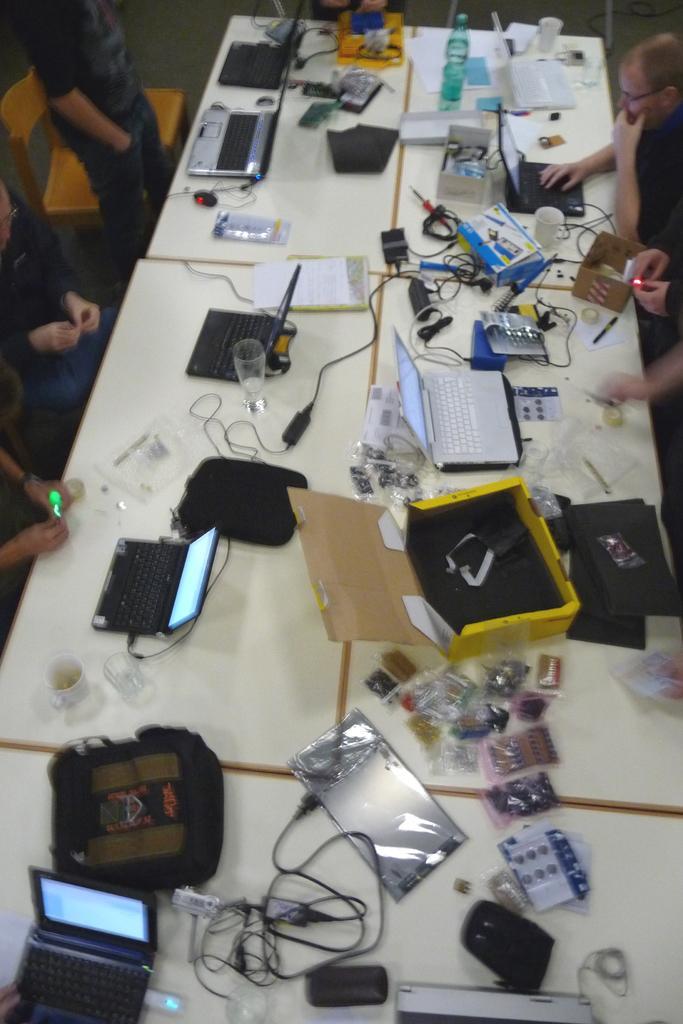Describe this image in one or two sentences. In this image in the center there is a table which is white in colour and on the table there are laptops, wires and there is a bag and there are objects which are black in colour and on the left side of the table there is a man standing and there are persons. On the right side of the table there is a man working on a laptop which is in front of him and the hand of the person is visible. 